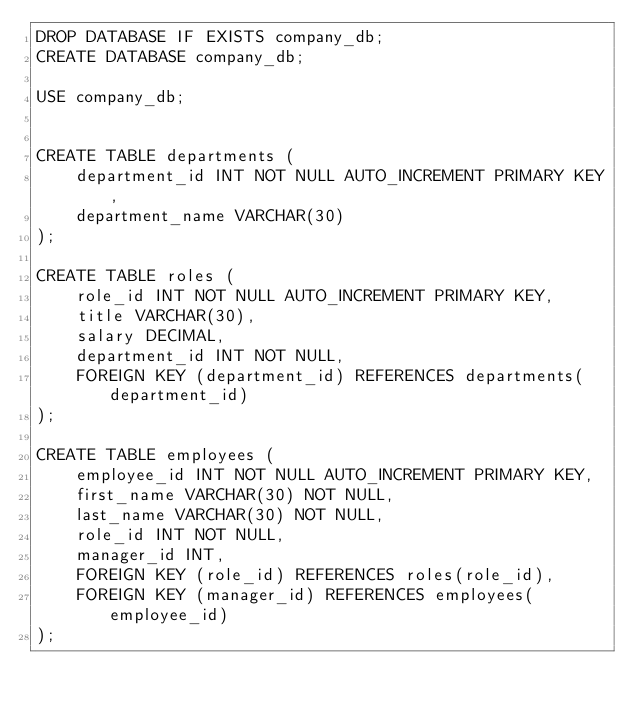<code> <loc_0><loc_0><loc_500><loc_500><_SQL_>DROP DATABASE IF EXISTS company_db;
CREATE DATABASE company_db;

USE company_db;


CREATE TABLE departments (
    department_id INT NOT NULL AUTO_INCREMENT PRIMARY KEY,
    department_name VARCHAR(30)
);

CREATE TABLE roles (
    role_id INT NOT NULL AUTO_INCREMENT PRIMARY KEY,
    title VARCHAR(30),
    salary DECIMAL,
    department_id INT NOT NULL,
    FOREIGN KEY (department_id) REFERENCES departments(department_id)
);

CREATE TABLE employees (
    employee_id INT NOT NULL AUTO_INCREMENT PRIMARY KEY,
    first_name VARCHAR(30) NOT NULL,
    last_name VARCHAR(30) NOT NULL,
    role_id INT NOT NULL,
    manager_id INT,
    FOREIGN KEY (role_id) REFERENCES roles(role_id),
    FOREIGN KEY (manager_id) REFERENCES employees(employee_id)
);
</code> 